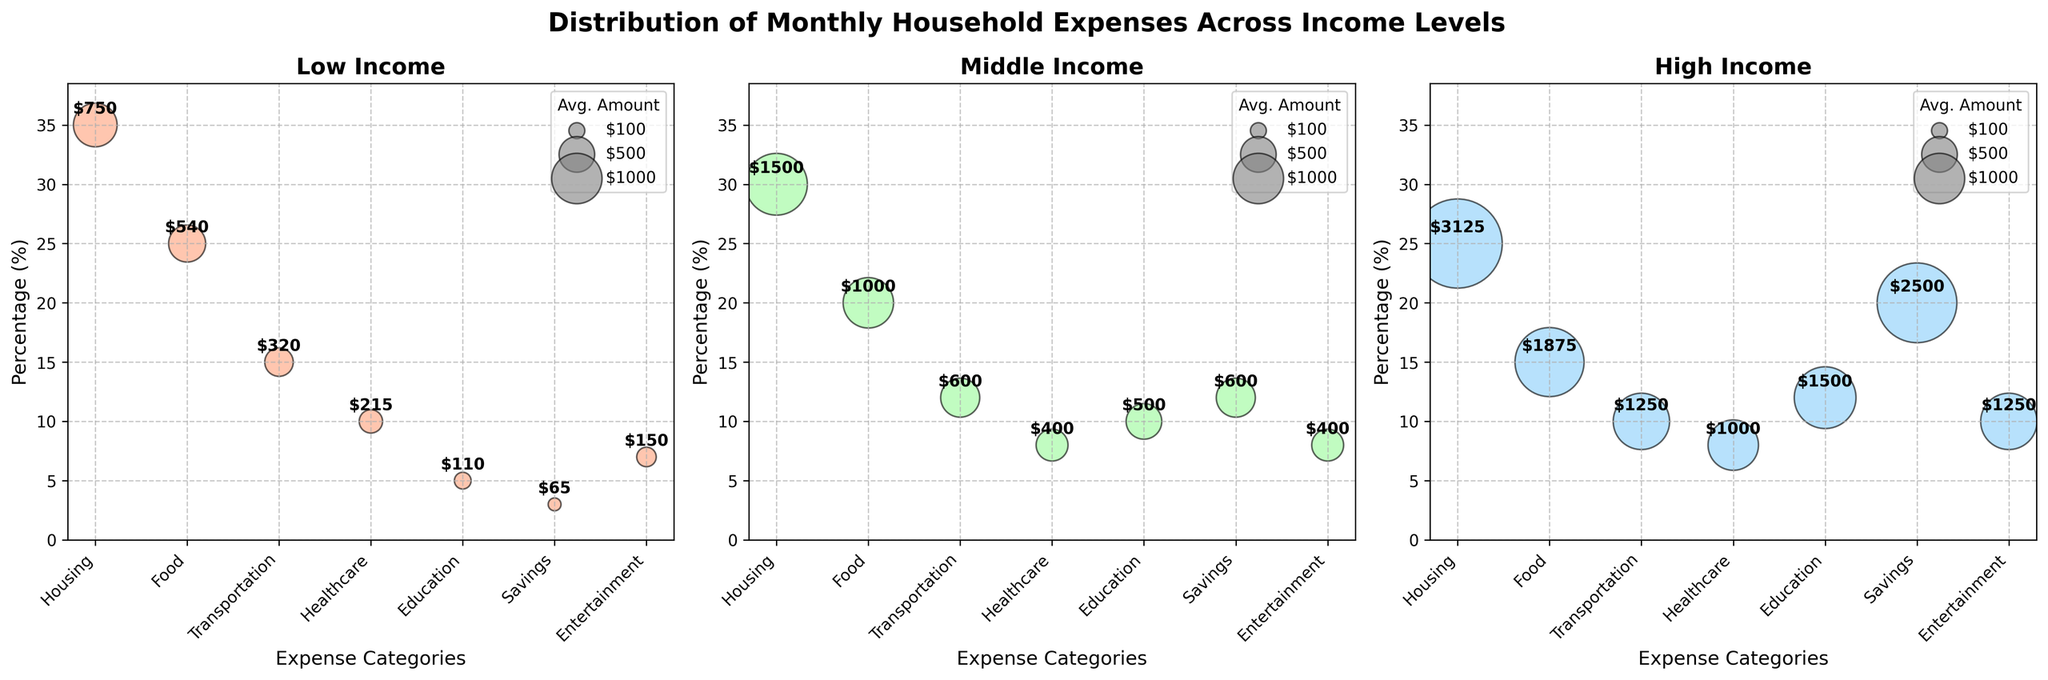What is the title of the figure? The figure's title is located at the top center and provides an overview of what the plot represents.
Answer: Distribution of Monthly Household Expenses Across Income Levels Which income level spends the highest percentage on housing? To find this, look at the y-axis (percentage) for housing in each of the three subplots (Low Income, Middle Income, High Income). The highest value can be found in the Low Income subgroup.
Answer: Low Income How does the percentage spent on education compare between middle and high income levels? First, find the percentage for education in the middle and high-income subplots by looking at the respective y-values. Middle income has 10%, and high income has 12%. Compare these two values.
Answer: High income spends 2% more What is the average amount spent on food by low-income households? Locate the 'Food' bubble in the Low Income subplot and read the annotation inside the bubble, which represents the average amount spent.
Answer: $540 Which expense category has the smallest average amount for middle-income households? In the Middle Income subplot, look for the bubble with the smallest size, which corresponds to the smallest average amount. This information can be found in the legend as well.
Answer: Healthcare ($400) Between middle and high-income households, which group allocates a higher percentage to savings? Compare the 'Savings' percentages by identifying the corresponding y-values in the middle and high-income subplots. Middle income allocates 12%, while high income allocates 20%.
Answer: High income Are there any expense categories that low-income households spend more on (as a percentage) compared to high-income households? Compare the y-values of each category between low-income and high-income subplots. Low-income percentages exceed high-income percentages in 'Housing,' 'Food,' and 'Transportation.'
Answer: Housing, Food, and Transportation Which income level puts the highest percentage of their expenses into savings? Determine the largest y-value associated with 'Savings' among the three subplots. The high-income group allocates the highest percentage here.
Answer: High Income How do the average amounts spent on entertainment compare across all three income levels? Find and compare the annotated average amounts for 'Entertainment' in each subplot. Low income: $150, Middle income: $400, High income: $1250.
Answer: Low < Middle < High What is the combined percentage spent on healthcare and education for low-income households? Sum the percentages for 'Healthcare' (10%) and 'Education' (5%) in the Low Income subplot.
Answer: 15% 